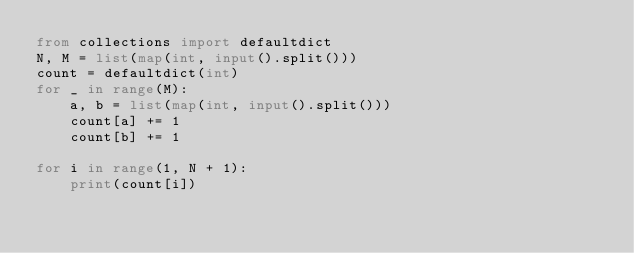<code> <loc_0><loc_0><loc_500><loc_500><_Python_>from collections import defaultdict
N, M = list(map(int, input().split()))
count = defaultdict(int)
for _ in range(M):
    a, b = list(map(int, input().split()))
    count[a] += 1
    count[b] += 1

for i in range(1, N + 1):
    print(count[i])</code> 